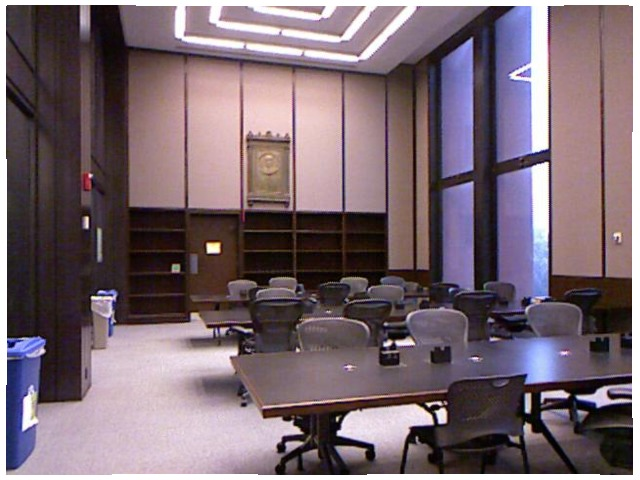<image>
Can you confirm if the table is in front of the chair? Yes. The table is positioned in front of the chair, appearing closer to the camera viewpoint. Is the recycling bin next to the trash can? No. The recycling bin is not positioned next to the trash can. They are located in different areas of the scene. Is the chair behind the table? Yes. From this viewpoint, the chair is positioned behind the table, with the table partially or fully occluding the chair. 